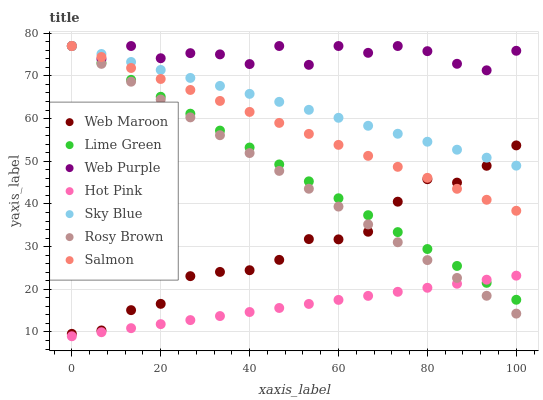Does Hot Pink have the minimum area under the curve?
Answer yes or no. Yes. Does Web Purple have the maximum area under the curve?
Answer yes or no. Yes. Does Salmon have the minimum area under the curve?
Answer yes or no. No. Does Salmon have the maximum area under the curve?
Answer yes or no. No. Is Hot Pink the smoothest?
Answer yes or no. Yes. Is Web Purple the roughest?
Answer yes or no. Yes. Is Salmon the smoothest?
Answer yes or no. No. Is Salmon the roughest?
Answer yes or no. No. Does Hot Pink have the lowest value?
Answer yes or no. Yes. Does Salmon have the lowest value?
Answer yes or no. No. Does Lime Green have the highest value?
Answer yes or no. Yes. Does Hot Pink have the highest value?
Answer yes or no. No. Is Hot Pink less than Web Maroon?
Answer yes or no. Yes. Is Salmon greater than Hot Pink?
Answer yes or no. Yes. Does Salmon intersect Sky Blue?
Answer yes or no. Yes. Is Salmon less than Sky Blue?
Answer yes or no. No. Is Salmon greater than Sky Blue?
Answer yes or no. No. Does Hot Pink intersect Web Maroon?
Answer yes or no. No. 